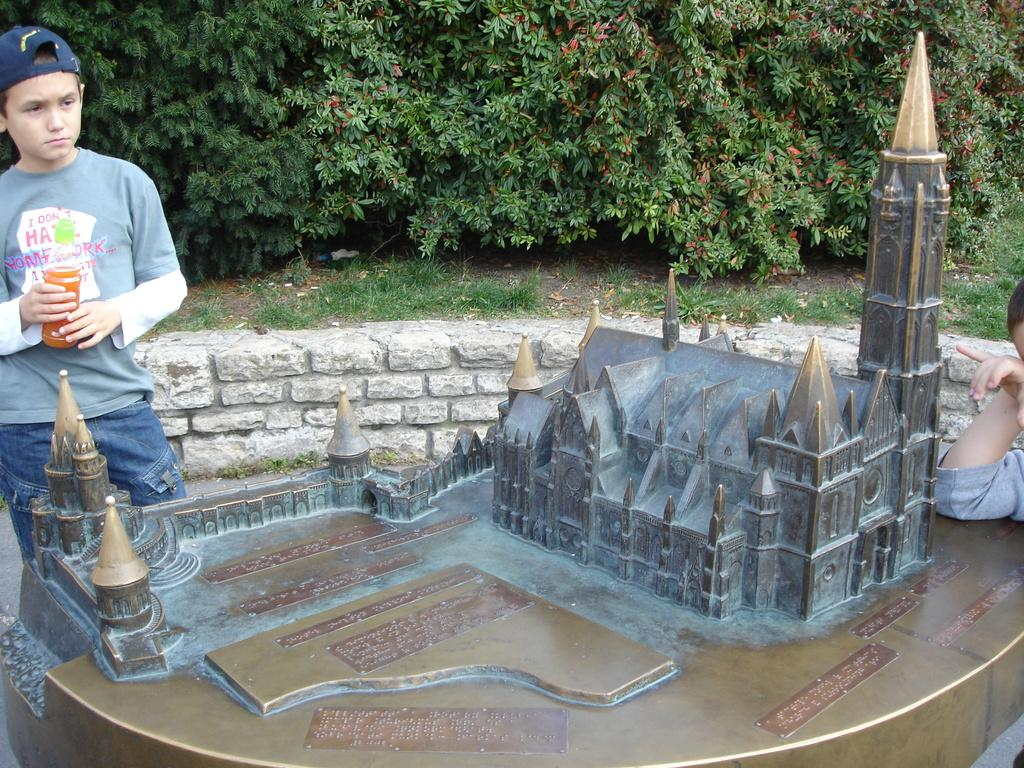What is the main subject of the image? There is a depiction of a building in the image. Are there any people in the image? Yes, two people are standing beside the building. What can be seen in the background of the image? There is a brick wall and trees in the background of the image. What type of wound can be seen on the building in the image? There is no wound present on the building in the image. What scale is used to measure the height of the trees in the background? There is no scale present in the image to measure the height of the trees. 